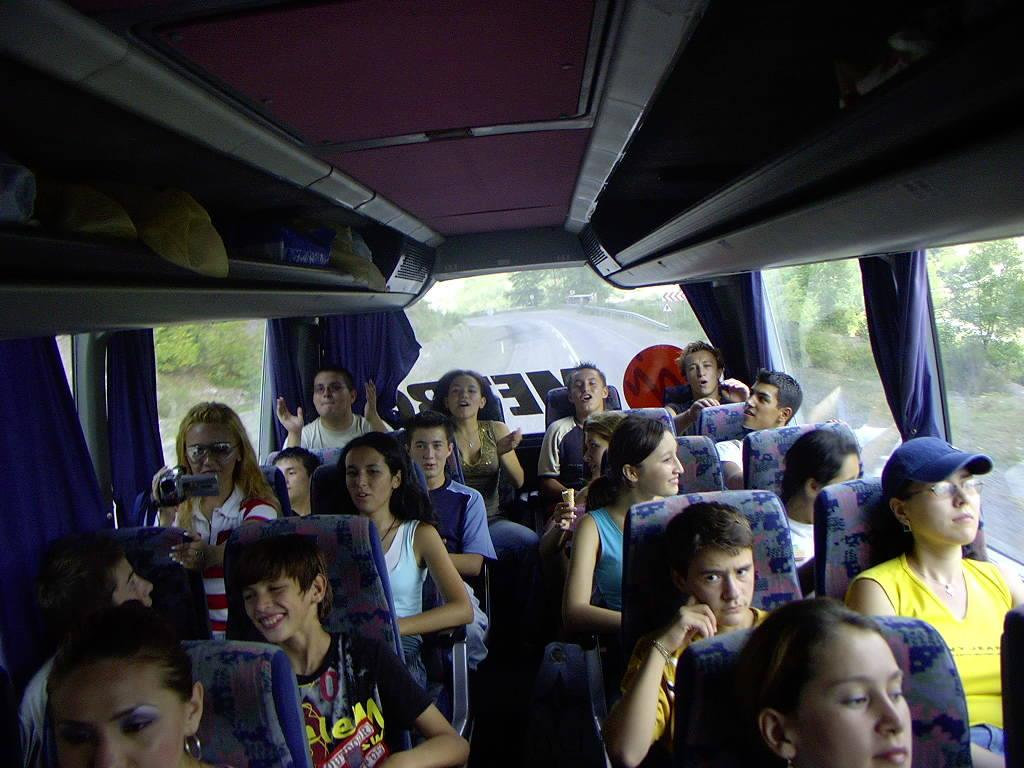What is the main subject of the image? The main subject of the image is a group of people. What are the people doing in the image? The people are sitting on chairs in the image. Where are the chairs located? The chairs are in a bus. What can be seen in the background of the image? There is a road and trees visible in the background of the image. What type of kite is being flown by the army in the image? There is no army or kite present in the image. How many bags of popcorn are visible in the image? There are no bags of popcorn present in the image. 